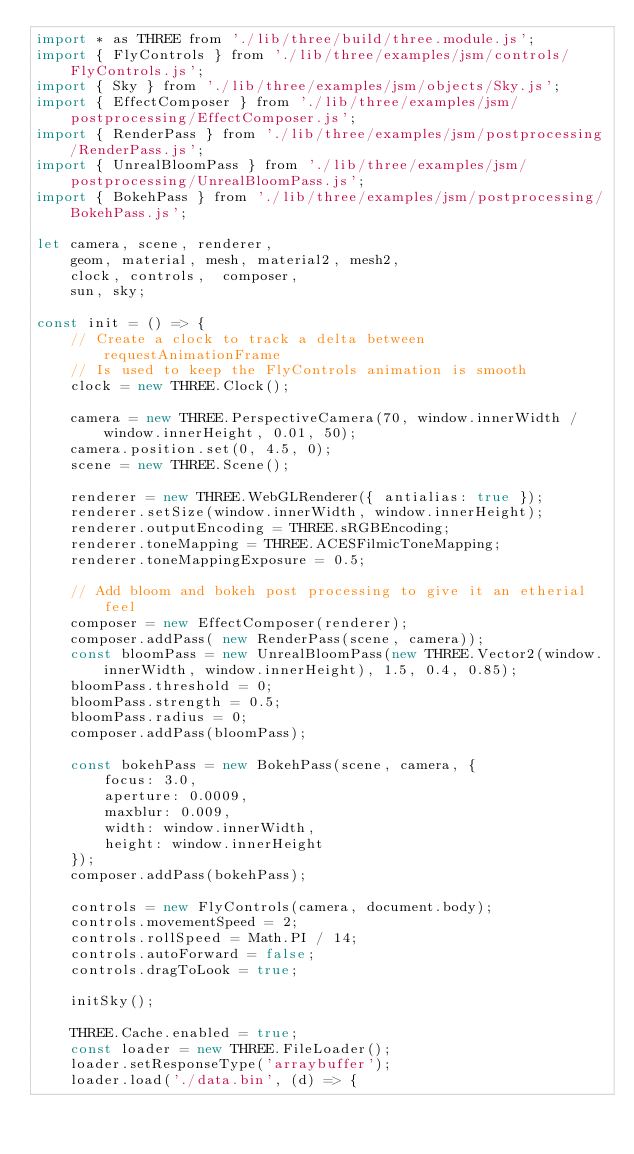<code> <loc_0><loc_0><loc_500><loc_500><_JavaScript_>import * as THREE from './lib/three/build/three.module.js';
import { FlyControls } from './lib/three/examples/jsm/controls/FlyControls.js';
import { Sky } from './lib/three/examples/jsm/objects/Sky.js';
import { EffectComposer } from './lib/three/examples/jsm/postprocessing/EffectComposer.js';
import { RenderPass } from './lib/three/examples/jsm/postprocessing/RenderPass.js';
import { UnrealBloomPass } from './lib/three/examples/jsm/postprocessing/UnrealBloomPass.js';
import { BokehPass } from './lib/three/examples/jsm/postprocessing/BokehPass.js';

let camera, scene, renderer,
    geom, material, mesh, material2, mesh2,
    clock, controls,  composer,
    sun, sky;

const init = () => {
    // Create a clock to track a delta between requestAnimationFrame
    // Is used to keep the FlyControls animation is smooth
    clock = new THREE.Clock();

    camera = new THREE.PerspectiveCamera(70, window.innerWidth / window.innerHeight, 0.01, 50);
    camera.position.set(0, 4.5, 0);
    scene = new THREE.Scene();

    renderer = new THREE.WebGLRenderer({ antialias: true });
    renderer.setSize(window.innerWidth, window.innerHeight);
    renderer.outputEncoding = THREE.sRGBEncoding;
    renderer.toneMapping = THREE.ACESFilmicToneMapping;
    renderer.toneMappingExposure = 0.5;

    // Add bloom and bokeh post processing to give it an etherial feel
    composer = new EffectComposer(renderer);
    composer.addPass( new RenderPass(scene, camera));
    const bloomPass = new UnrealBloomPass(new THREE.Vector2(window.innerWidth, window.innerHeight), 1.5, 0.4, 0.85);
    bloomPass.threshold = 0;
    bloomPass.strength = 0.5;
    bloomPass.radius = 0;
    composer.addPass(bloomPass);

    const bokehPass = new BokehPass(scene, camera, {
        focus: 3.0,
        aperture: 0.0009,
        maxblur: 0.009,
        width: window.innerWidth,
        height: window.innerHeight
    });
    composer.addPass(bokehPass);

    controls = new FlyControls(camera, document.body);
    controls.movementSpeed = 2;
    controls.rollSpeed = Math.PI / 14;
    controls.autoForward = false;
    controls.dragToLook = true;

    initSky();

    THREE.Cache.enabled = true;
    const loader = new THREE.FileLoader();
    loader.setResponseType('arraybuffer');
    loader.load('./data.bin', (d) => {</code> 